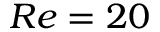Convert formula to latex. <formula><loc_0><loc_0><loc_500><loc_500>R e = 2 0</formula> 